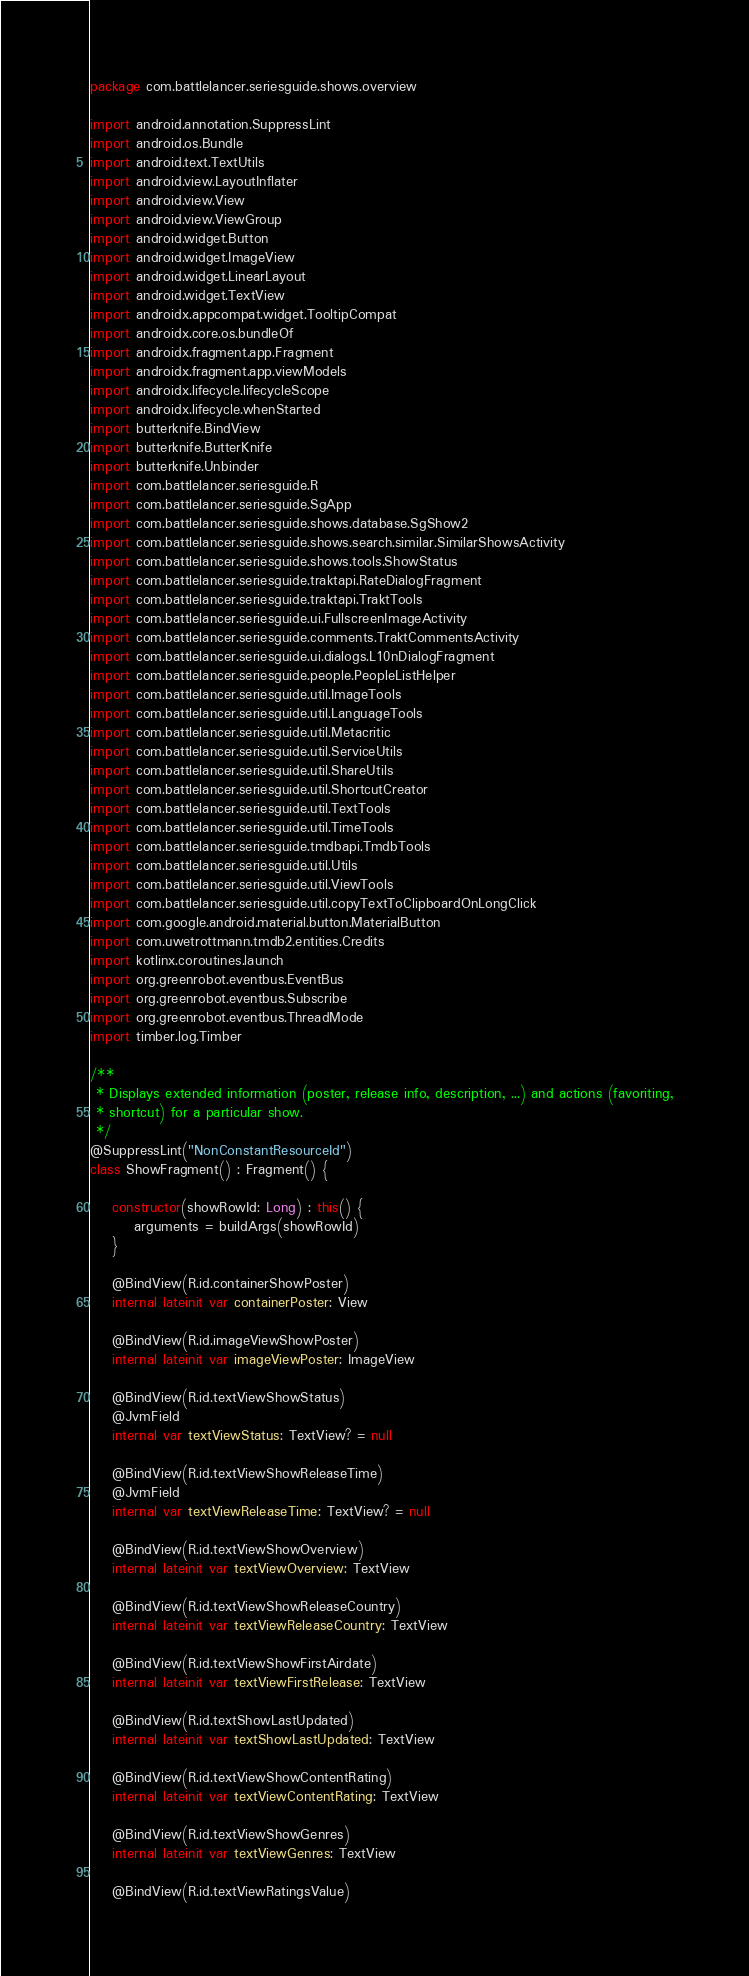Convert code to text. <code><loc_0><loc_0><loc_500><loc_500><_Kotlin_>package com.battlelancer.seriesguide.shows.overview

import android.annotation.SuppressLint
import android.os.Bundle
import android.text.TextUtils
import android.view.LayoutInflater
import android.view.View
import android.view.ViewGroup
import android.widget.Button
import android.widget.ImageView
import android.widget.LinearLayout
import android.widget.TextView
import androidx.appcompat.widget.TooltipCompat
import androidx.core.os.bundleOf
import androidx.fragment.app.Fragment
import androidx.fragment.app.viewModels
import androidx.lifecycle.lifecycleScope
import androidx.lifecycle.whenStarted
import butterknife.BindView
import butterknife.ButterKnife
import butterknife.Unbinder
import com.battlelancer.seriesguide.R
import com.battlelancer.seriesguide.SgApp
import com.battlelancer.seriesguide.shows.database.SgShow2
import com.battlelancer.seriesguide.shows.search.similar.SimilarShowsActivity
import com.battlelancer.seriesguide.shows.tools.ShowStatus
import com.battlelancer.seriesguide.traktapi.RateDialogFragment
import com.battlelancer.seriesguide.traktapi.TraktTools
import com.battlelancer.seriesguide.ui.FullscreenImageActivity
import com.battlelancer.seriesguide.comments.TraktCommentsActivity
import com.battlelancer.seriesguide.ui.dialogs.L10nDialogFragment
import com.battlelancer.seriesguide.people.PeopleListHelper
import com.battlelancer.seriesguide.util.ImageTools
import com.battlelancer.seriesguide.util.LanguageTools
import com.battlelancer.seriesguide.util.Metacritic
import com.battlelancer.seriesguide.util.ServiceUtils
import com.battlelancer.seriesguide.util.ShareUtils
import com.battlelancer.seriesguide.util.ShortcutCreator
import com.battlelancer.seriesguide.util.TextTools
import com.battlelancer.seriesguide.util.TimeTools
import com.battlelancer.seriesguide.tmdbapi.TmdbTools
import com.battlelancer.seriesguide.util.Utils
import com.battlelancer.seriesguide.util.ViewTools
import com.battlelancer.seriesguide.util.copyTextToClipboardOnLongClick
import com.google.android.material.button.MaterialButton
import com.uwetrottmann.tmdb2.entities.Credits
import kotlinx.coroutines.launch
import org.greenrobot.eventbus.EventBus
import org.greenrobot.eventbus.Subscribe
import org.greenrobot.eventbus.ThreadMode
import timber.log.Timber

/**
 * Displays extended information (poster, release info, description, ...) and actions (favoriting,
 * shortcut) for a particular show.
 */
@SuppressLint("NonConstantResourceId")
class ShowFragment() : Fragment() {

    constructor(showRowId: Long) : this() {
        arguments = buildArgs(showRowId)
    }

    @BindView(R.id.containerShowPoster)
    internal lateinit var containerPoster: View

    @BindView(R.id.imageViewShowPoster)
    internal lateinit var imageViewPoster: ImageView

    @BindView(R.id.textViewShowStatus)
    @JvmField
    internal var textViewStatus: TextView? = null

    @BindView(R.id.textViewShowReleaseTime)
    @JvmField
    internal var textViewReleaseTime: TextView? = null

    @BindView(R.id.textViewShowOverview)
    internal lateinit var textViewOverview: TextView

    @BindView(R.id.textViewShowReleaseCountry)
    internal lateinit var textViewReleaseCountry: TextView

    @BindView(R.id.textViewShowFirstAirdate)
    internal lateinit var textViewFirstRelease: TextView

    @BindView(R.id.textShowLastUpdated)
    internal lateinit var textShowLastUpdated: TextView

    @BindView(R.id.textViewShowContentRating)
    internal lateinit var textViewContentRating: TextView

    @BindView(R.id.textViewShowGenres)
    internal lateinit var textViewGenres: TextView

    @BindView(R.id.textViewRatingsValue)</code> 